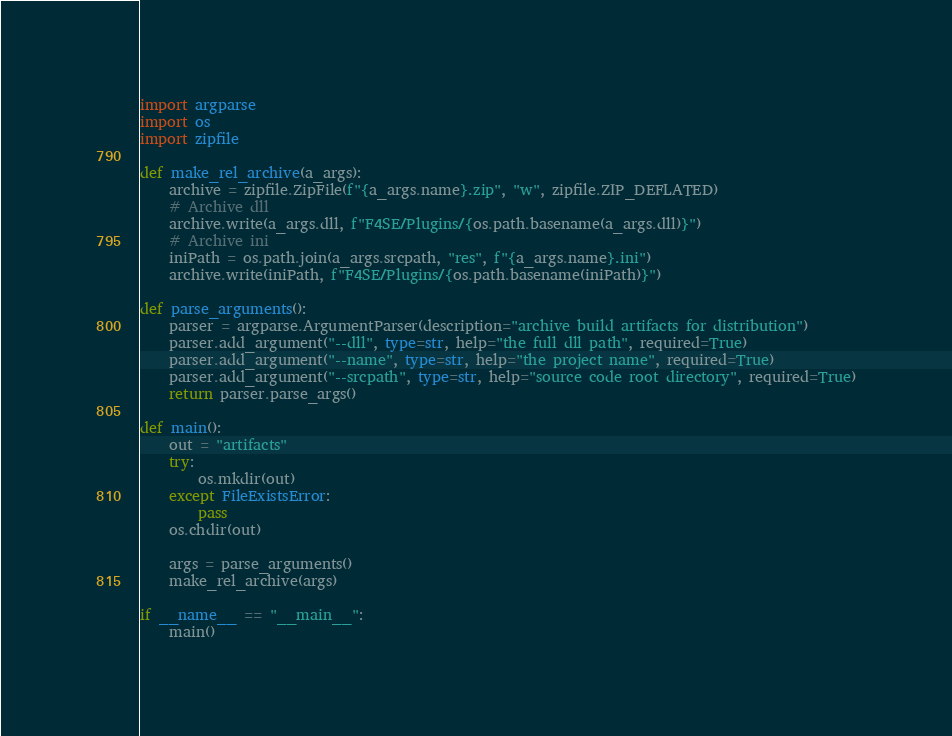Convert code to text. <code><loc_0><loc_0><loc_500><loc_500><_Python_>import argparse
import os
import zipfile

def make_rel_archive(a_args):
	archive = zipfile.ZipFile(f"{a_args.name}.zip", "w", zipfile.ZIP_DEFLATED)
	# Archive dll
	archive.write(a_args.dll, f"F4SE/Plugins/{os.path.basename(a_args.dll)}")
	# Archive ini
	iniPath = os.path.join(a_args.srcpath, "res", f"{a_args.name}.ini")
	archive.write(iniPath, f"F4SE/Plugins/{os.path.basename(iniPath)}")

def parse_arguments():
	parser = argparse.ArgumentParser(description="archive build artifacts for distribution")
	parser.add_argument("--dll", type=str, help="the full dll path", required=True)
	parser.add_argument("--name", type=str, help="the project name", required=True)
	parser.add_argument("--srcpath", type=str, help="source code root directory", required=True)
	return parser.parse_args()

def main():
	out = "artifacts"
	try:
		os.mkdir(out)
	except FileExistsError:
		pass
	os.chdir(out)

	args = parse_arguments()
	make_rel_archive(args)

if __name__ == "__main__":
	main()
</code> 